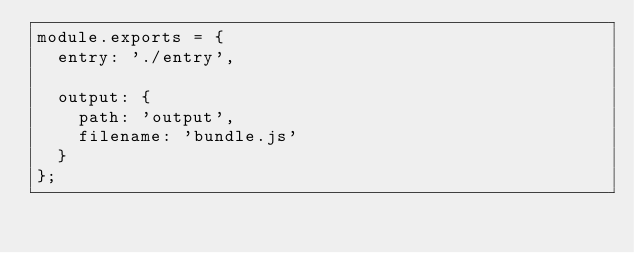<code> <loc_0><loc_0><loc_500><loc_500><_JavaScript_>module.exports = {
  entry: './entry',

  output: {
    path: 'output',
    filename: 'bundle.js'
  }
};
</code> 